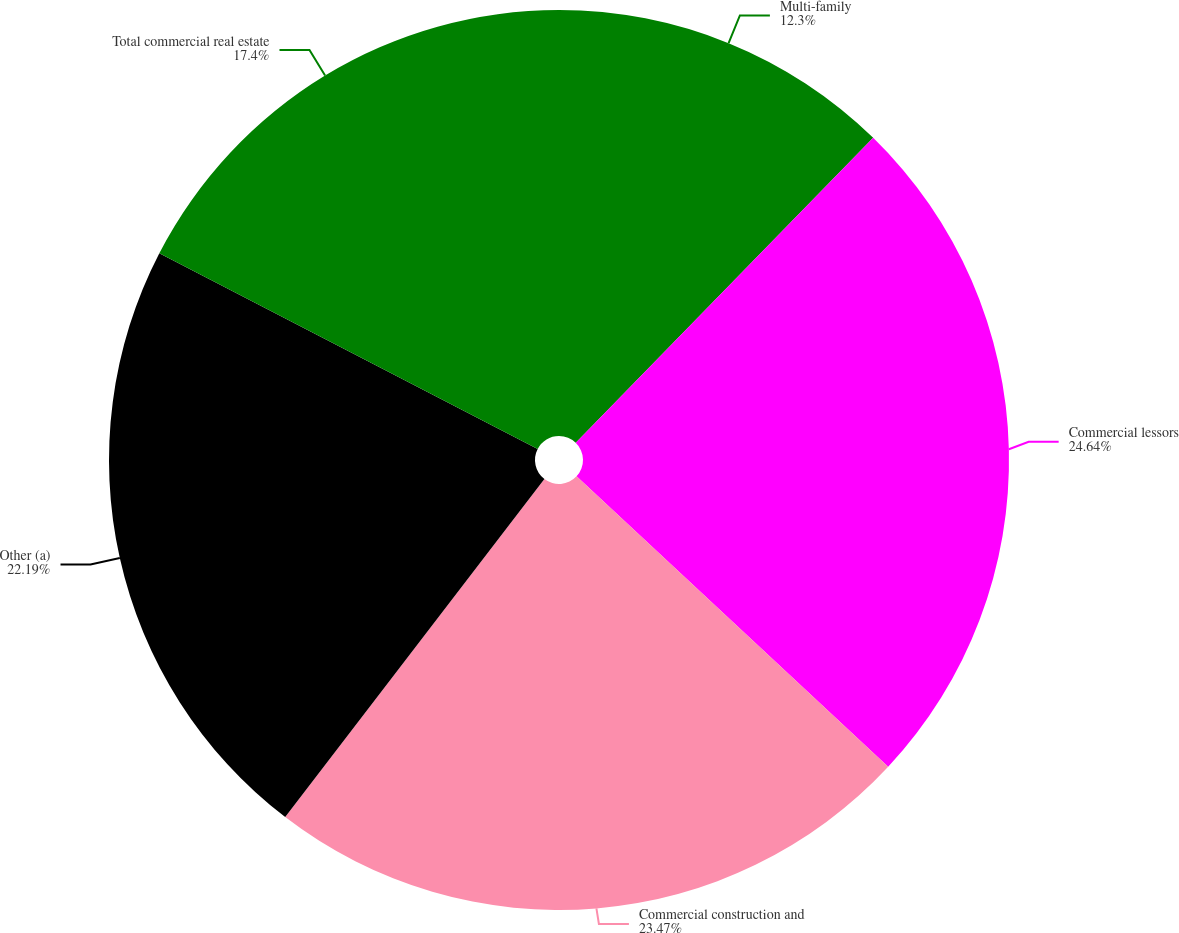Convert chart. <chart><loc_0><loc_0><loc_500><loc_500><pie_chart><fcel>Multi-family<fcel>Commercial lessors<fcel>Commercial construction and<fcel>Other (a)<fcel>Total commercial real estate<nl><fcel>12.3%<fcel>24.64%<fcel>23.47%<fcel>22.19%<fcel>17.4%<nl></chart> 